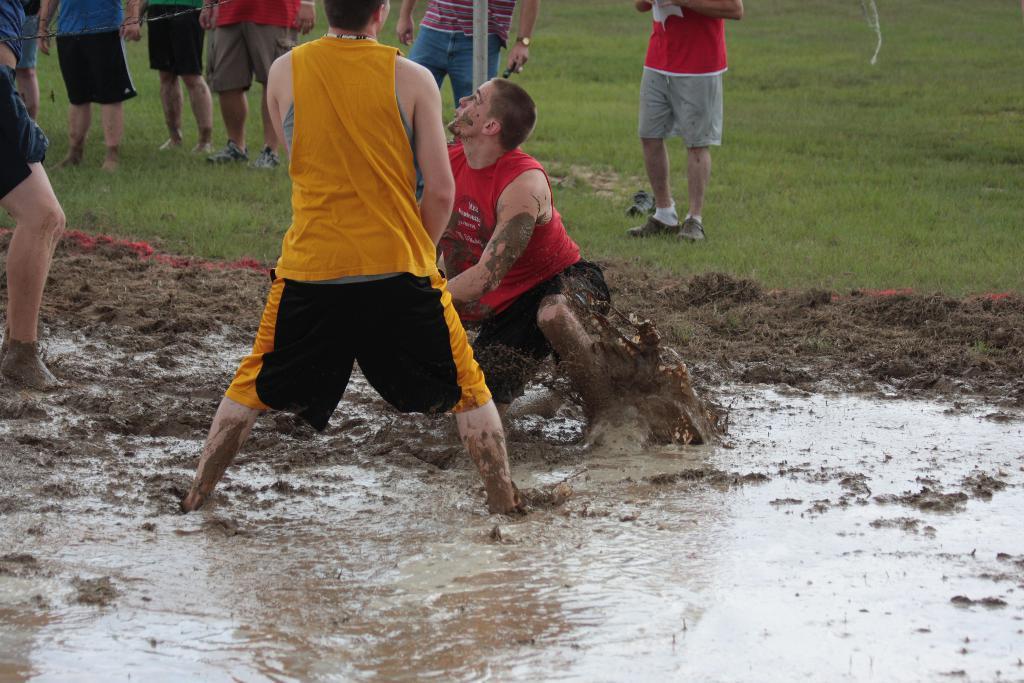In one or two sentences, can you explain what this image depicts? In this image there is water and mud at the bottom. There is a person on the left corner. There are people in the foreground. There are people standing, there is an object, there is grass in the background. 